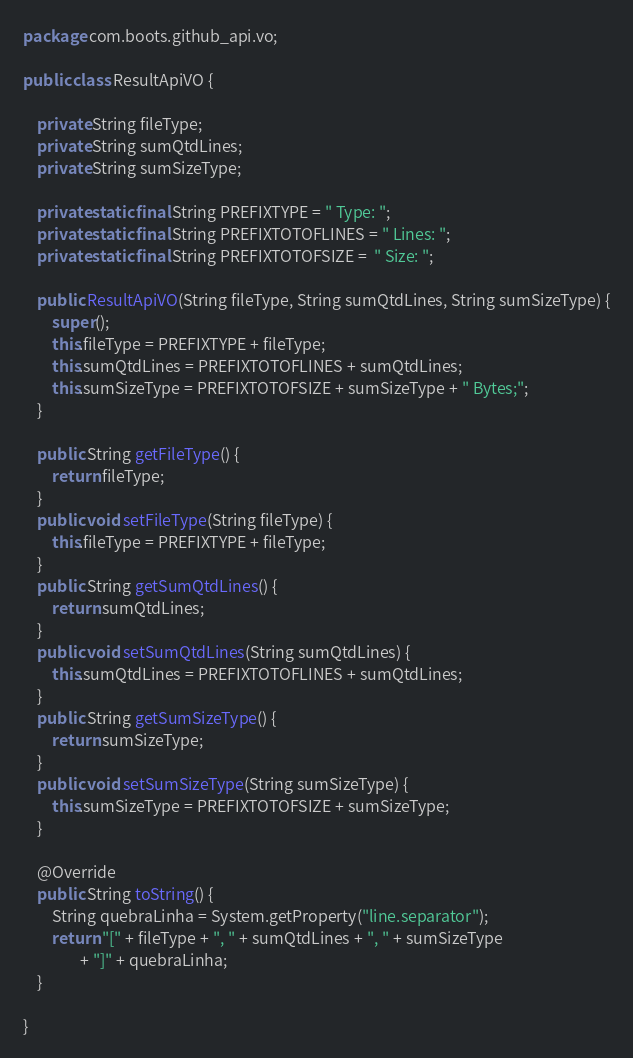Convert code to text. <code><loc_0><loc_0><loc_500><loc_500><_Java_>package com.boots.github_api.vo;

public class ResultApiVO {
	
	private String fileType;
	private String sumQtdLines;
	private String sumSizeType;
	
	private static final String PREFIXTYPE = " Type: ";
	private static final String PREFIXTOTOFLINES = " Lines: ";
	private static final String PREFIXTOTOFSIZE =  " Size: ";
	
	public ResultApiVO(String fileType, String sumQtdLines, String sumSizeType) {
		super();
		this.fileType = PREFIXTYPE + fileType;
		this.sumQtdLines = PREFIXTOTOFLINES + sumQtdLines;
		this.sumSizeType = PREFIXTOTOFSIZE + sumSizeType + " Bytes;";
	}
	
	public String getFileType() {
		return fileType;
	}
	public void setFileType(String fileType) {
		this.fileType = PREFIXTYPE + fileType;
	}
	public String getSumQtdLines() {
		return sumQtdLines;
	}
	public void setSumQtdLines(String sumQtdLines) {
		this.sumQtdLines = PREFIXTOTOFLINES + sumQtdLines;
	}
	public String getSumSizeType() {
		return sumSizeType;
	}
	public void setSumSizeType(String sumSizeType) {
		this.sumSizeType = PREFIXTOTOFSIZE + sumSizeType;
	}
	
	@Override
	public String toString() {
		String quebraLinha = System.getProperty("line.separator");
		return "[" + fileType + ", " + sumQtdLines + ", " + sumSizeType
				+ "]" + quebraLinha;
	}
			
}
</code> 